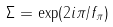<formula> <loc_0><loc_0><loc_500><loc_500>\Sigma = \exp ( 2 i \pi / f _ { \pi } )</formula> 